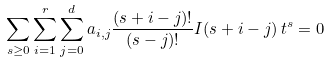<formula> <loc_0><loc_0><loc_500><loc_500>\sum _ { s \geq 0 } \sum _ { i = 1 } ^ { r } \sum _ { j = 0 } ^ { d } a _ { i , j } \frac { ( s + i - j ) ! } { ( s - j ) ! } I ( s + i - j ) \, t ^ { s } = 0</formula> 